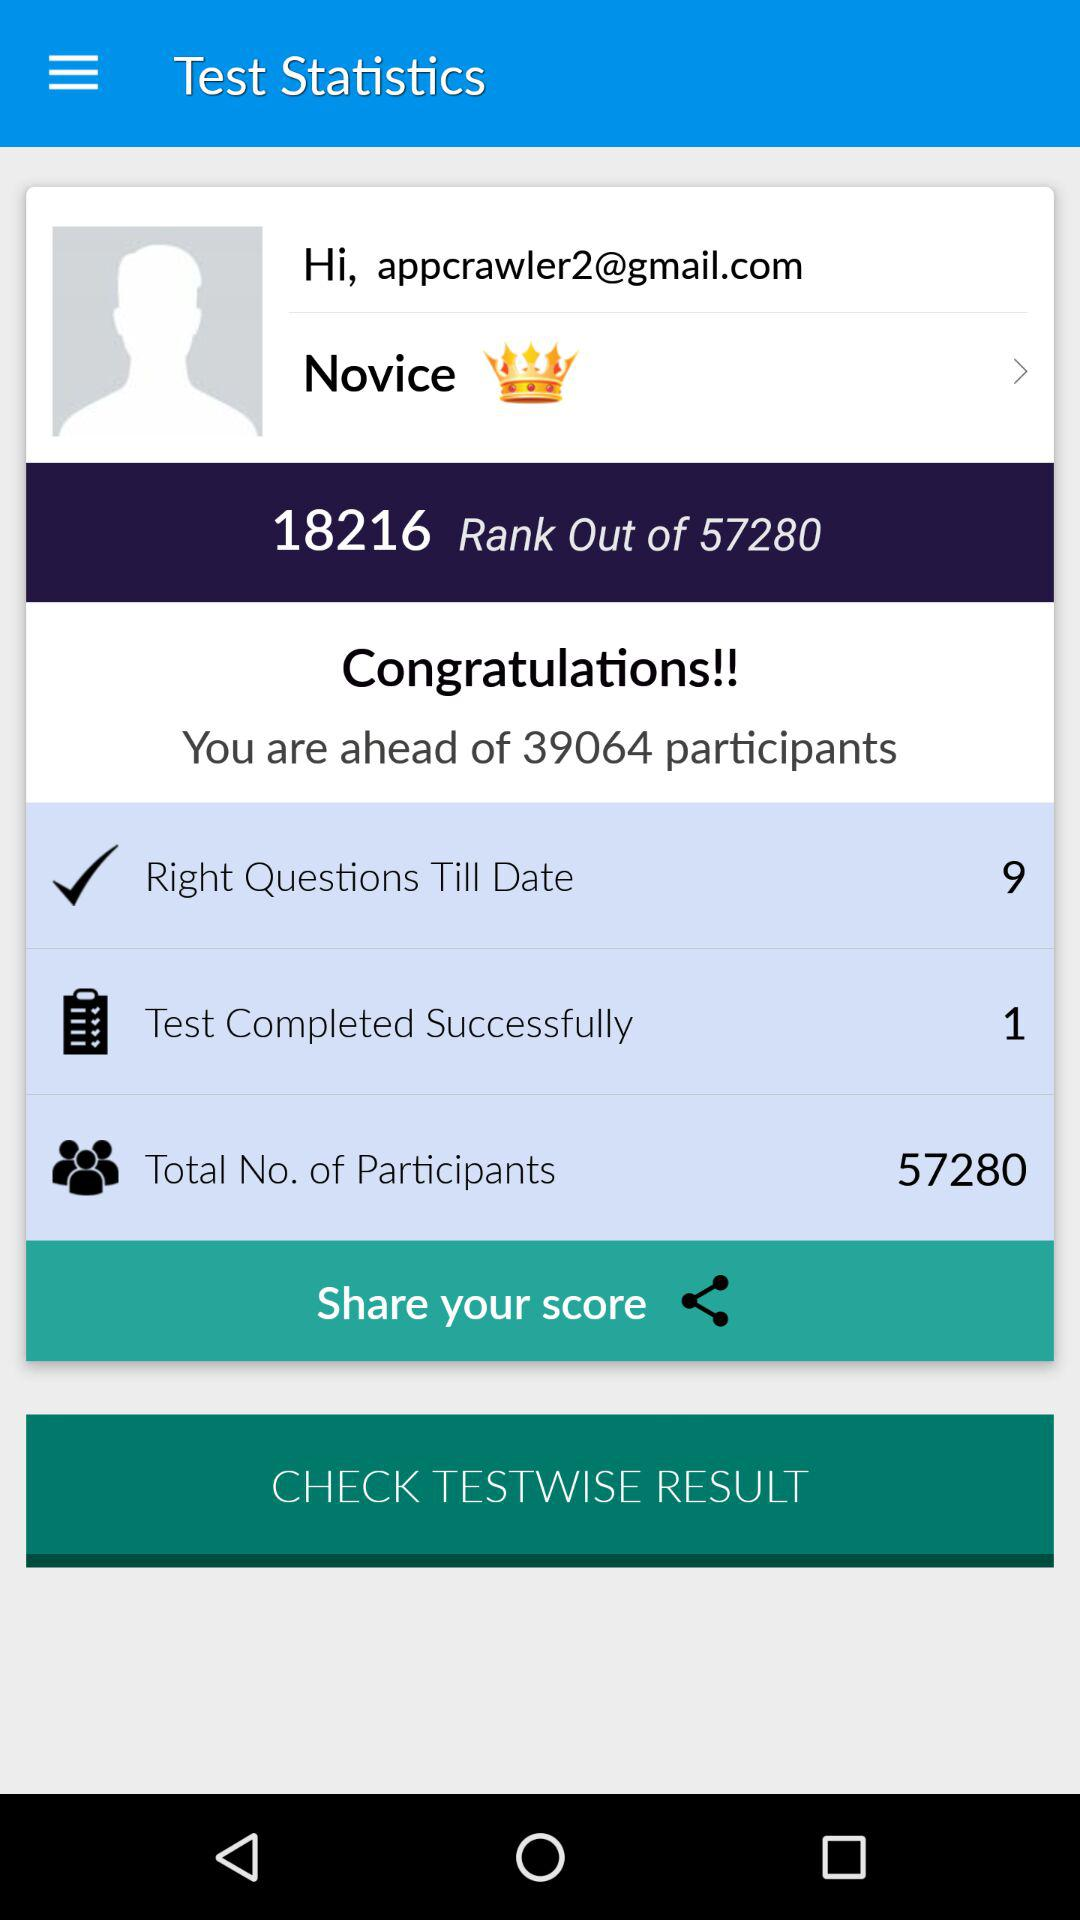What is the attained rank? The attained rank is 18216. 